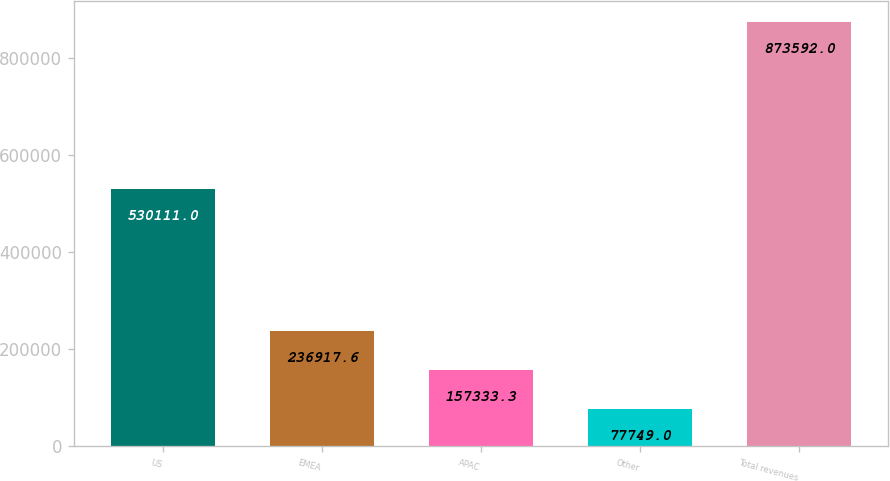Convert chart. <chart><loc_0><loc_0><loc_500><loc_500><bar_chart><fcel>US<fcel>EMEA<fcel>APAC<fcel>Other<fcel>Total revenues<nl><fcel>530111<fcel>236918<fcel>157333<fcel>77749<fcel>873592<nl></chart> 